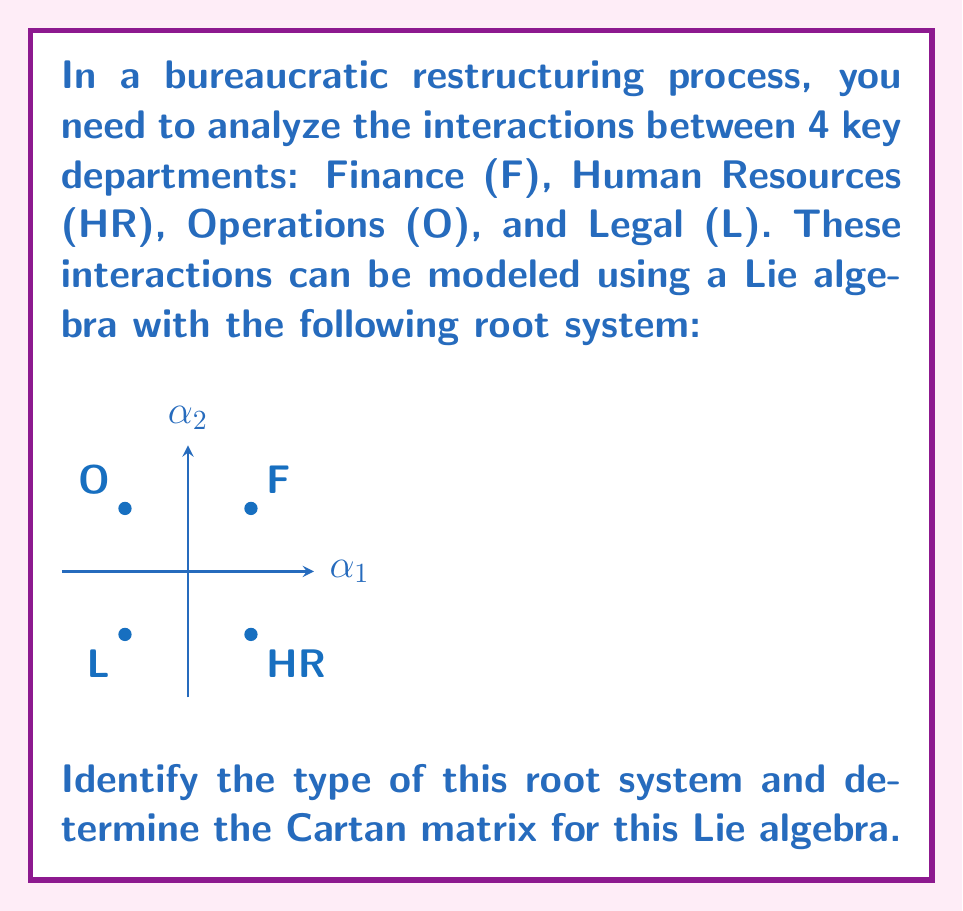Solve this math problem. To solve this problem, we'll follow these steps:

1) Identify the root system:
   The root system shown is a square with 4 roots at (±1, ±1). This is characteristic of the $A_2$ root system, which corresponds to the Lie algebra $\mathfrak{sl}(3, \mathbb{C})$.

2) Identify the simple roots:
   The simple roots are labeled in the diagram as $\alpha_1$ and $\alpha_2$. 
   $\alpha_1 = (1, 0)$ and $\alpha_2 = (0, 1)$

3) Calculate the angles between the simple roots:
   The angle between $\alpha_1$ and $\alpha_2$ is 90°, or $\frac{\pi}{2}$ radians.

4) Determine the length ratio of the simple roots:
   Both simple roots have the same length, so the ratio is 1:1.

5) Construct the Cartan matrix:
   The Cartan matrix $A = (a_{ij})$ is defined by:
   
   $a_{ij} = \frac{2(\alpha_i, \alpha_j)}{(\alpha_j, \alpha_j)}$

   Where $(\alpha_i, \alpha_j)$ is the inner product of roots $\alpha_i$ and $\alpha_j$.

   For $i = j$: $a_{ii} = 2$
   
   For $i \neq j$: $a_{ij} = -\cos(\theta_{ij}) \cdot \frac{|\alpha_i|}{|\alpha_j|}$
                 $= -\cos(\frac{\pi}{2}) \cdot 1 = 0$

   Therefore, the Cartan matrix is:

   $$A = \begin{pmatrix}
   2 & 0 \\
   0 & 2
   \end{pmatrix}$$

This Cartan matrix represents the interactions between departments, where diagonal elements indicate self-interactions and off-diagonal elements represent inter-departmental interactions.
Answer: Root system: $A_2$; Cartan matrix: $\begin{pmatrix} 2 & 0 \\ 0 & 2 \end{pmatrix}$ 